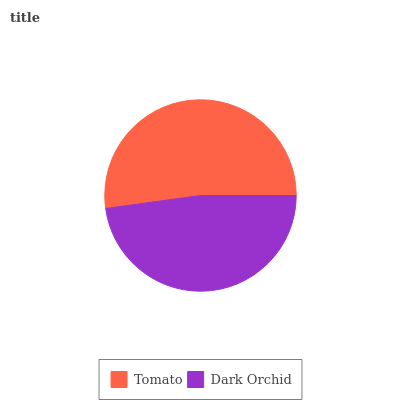Is Dark Orchid the minimum?
Answer yes or no. Yes. Is Tomato the maximum?
Answer yes or no. Yes. Is Dark Orchid the maximum?
Answer yes or no. No. Is Tomato greater than Dark Orchid?
Answer yes or no. Yes. Is Dark Orchid less than Tomato?
Answer yes or no. Yes. Is Dark Orchid greater than Tomato?
Answer yes or no. No. Is Tomato less than Dark Orchid?
Answer yes or no. No. Is Tomato the high median?
Answer yes or no. Yes. Is Dark Orchid the low median?
Answer yes or no. Yes. Is Dark Orchid the high median?
Answer yes or no. No. Is Tomato the low median?
Answer yes or no. No. 